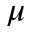<formula> <loc_0><loc_0><loc_500><loc_500>\mu</formula> 